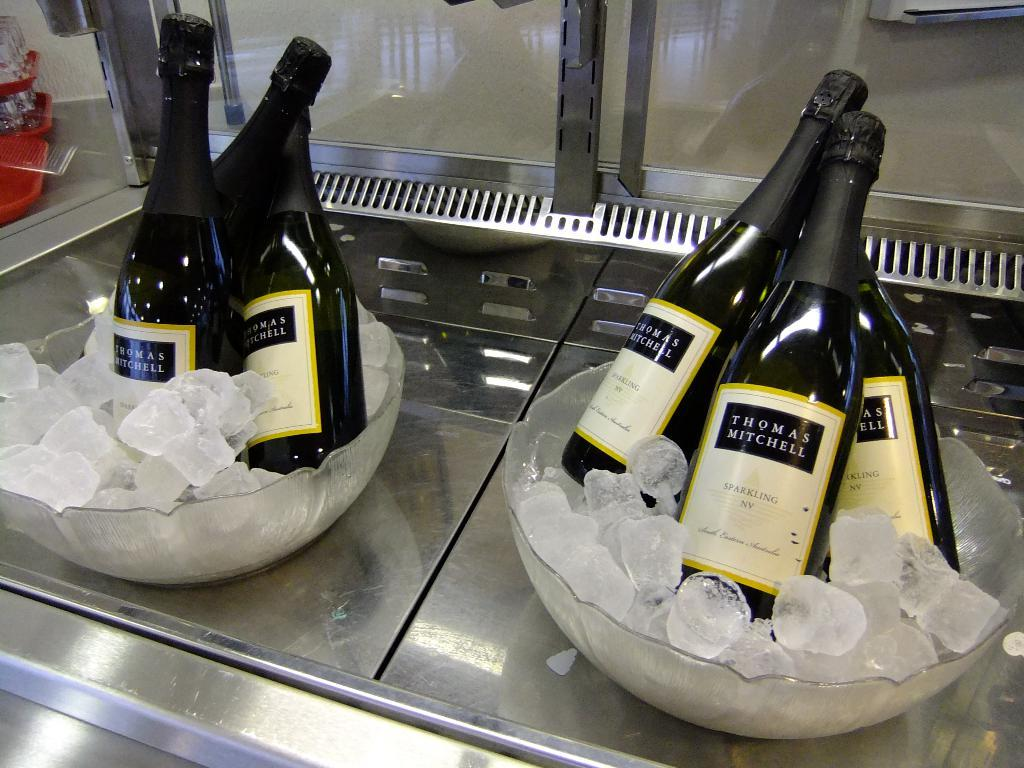How many bowls are visible in the image? There are two bowls in the image. What is inside the bowls? The bowls contain ice cubes. What type of objects are black in color in the image? There are black color bottles in the image. Where are the red trays located in the image? The red trays are on the left side of the image. How many records can be seen on the table in the image? There are no records present in the image. Can you describe the feet of the person in the image? There is no person present in the image. 